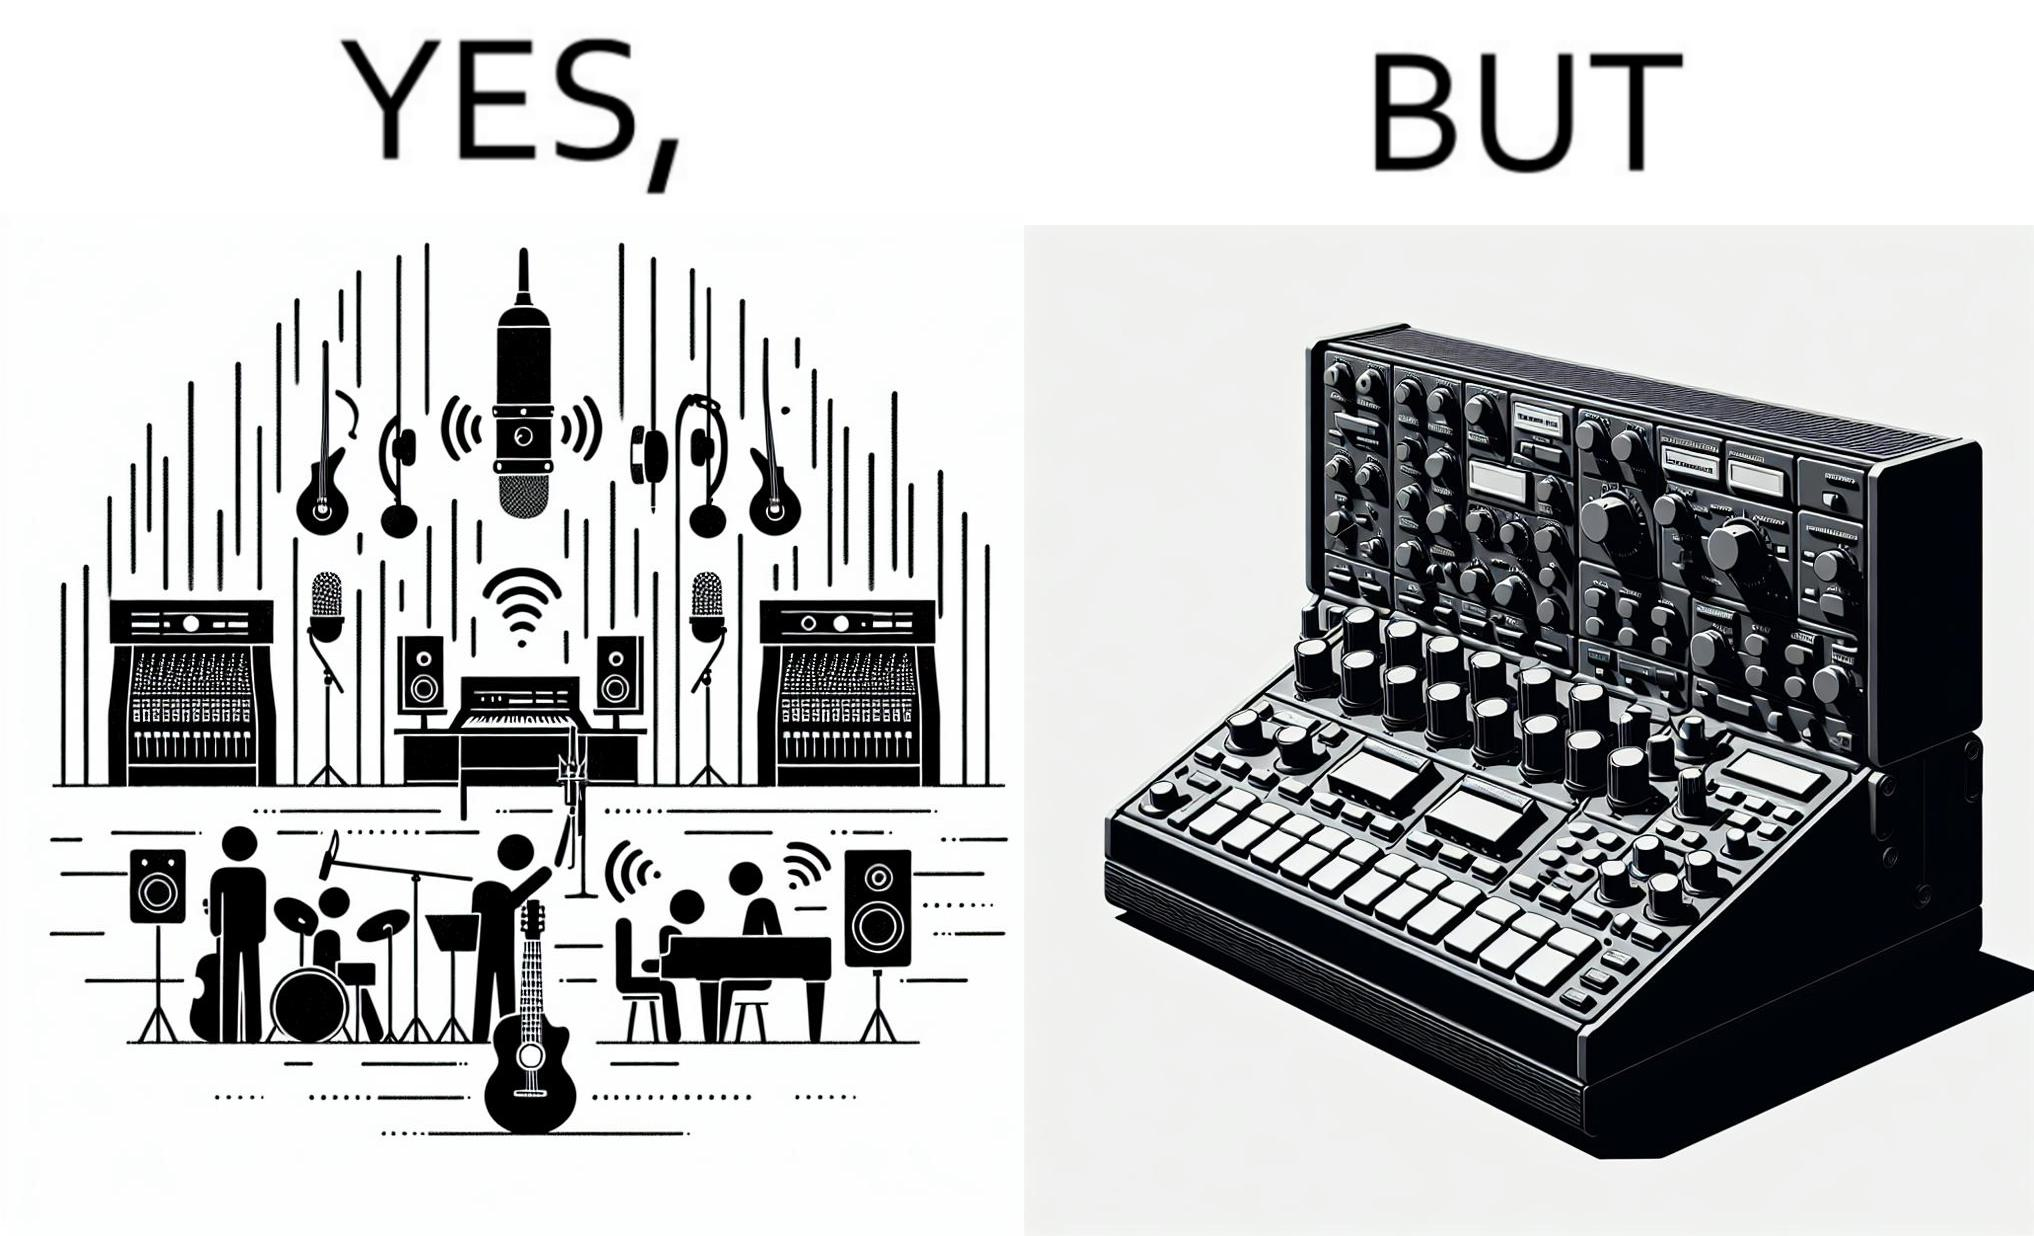What is shown in this image? The image overall is funny because even though people have great music studios and instruments to create and record music, they use electronic replacements of the musical instruments to achieve the task. 